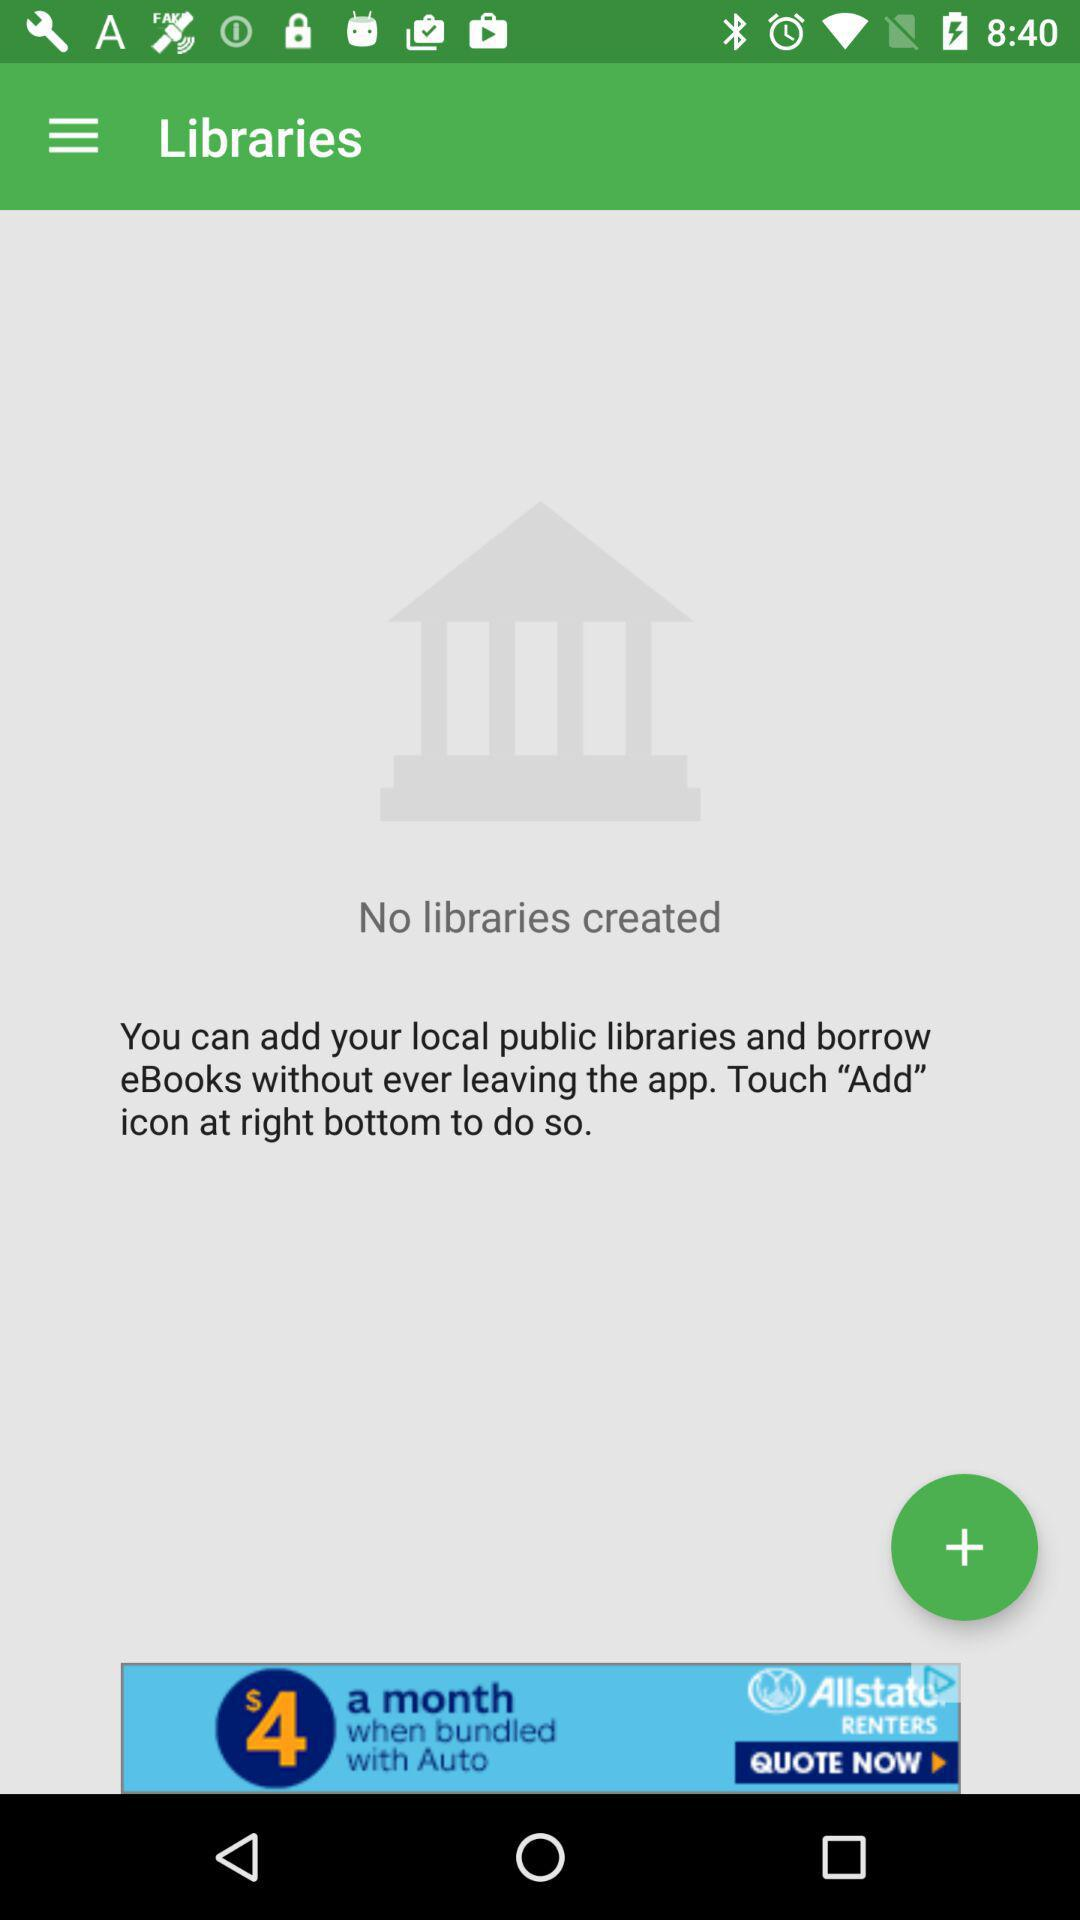How many libraries have I created?
Answer the question using a single word or phrase. 0 